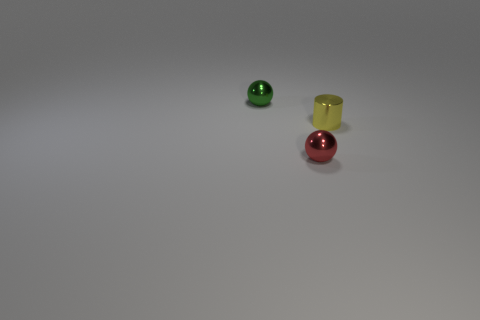Are the balls and the cup the same size? No, the balls appear to be smaller than the cup. The cup looks taller and slightly wider than the balls, suggesting a difference in scale. If these objects were part of a game, what do you think the rules would be? If this is a game setup, one possibility is that it's a sorting game, where the goal is to place the balls into cups of a matching color. Since there's no matching cup for the balls, perhaps the challenge involves using deduction or imagination, to decide where each ball should go. 